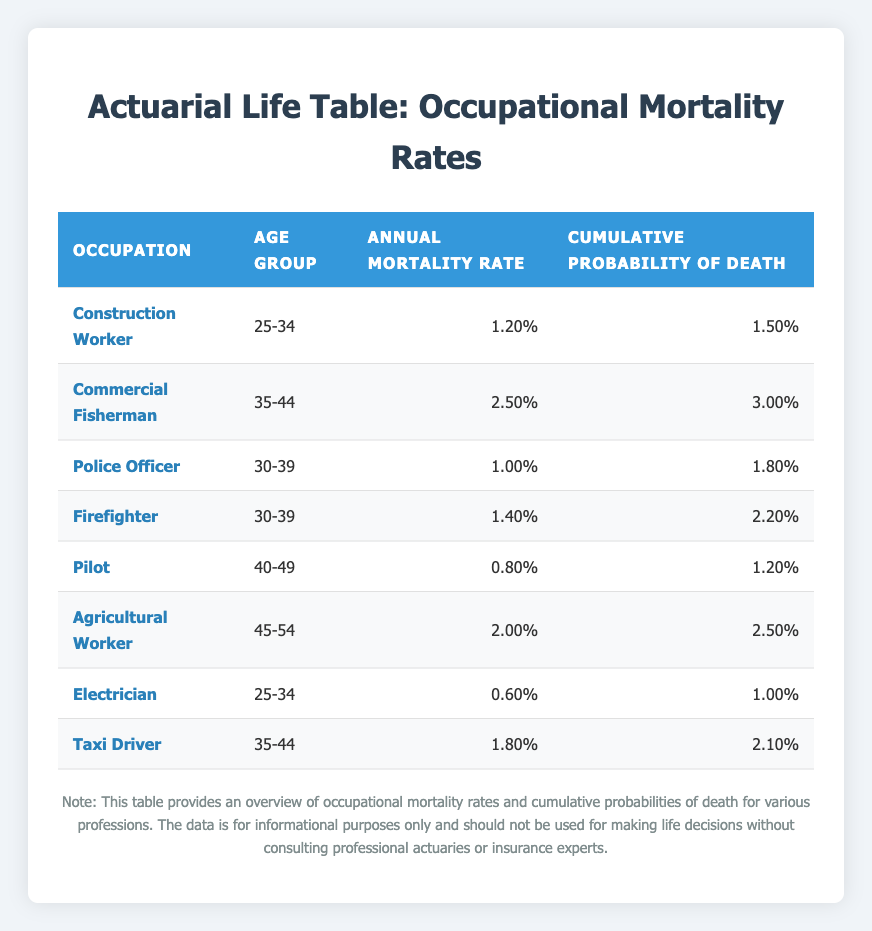What is the annual mortality rate for a Commercial Fisherman? The table lists the annual mortality rate for each occupation. For Commercial Fisherman, it is specifically mentioned as 2.50%.
Answer: 2.50% Which occupation has the highest cumulative probability of death in the age group 30-39? In the age group 30-39, there are two occupations: Police Officer with a cumulative probability of 1.80% and Firefighter with 2.20%. Firefighter has the highest cumulative probability of death at 2.20%.
Answer: Firefighter True or False: The annual mortality rate for Electricians is higher than that for Pilots. The annual mortality rate for Electricians is 0.60%, while for Pilots, it is 0.80%. Therefore, the statement is false since Electricians have a lower rate.
Answer: False What is the cumulative probability of death for Taxi Drivers in the 35-44 age group? The cumulative probability of death for Taxi Drivers in the age group 35-44 is explicitly stated in the table, which is 2.10%.
Answer: 2.10% If we average the annual mortality rates of Police Officers and Firefighters, what do we get? The annual mortality rate for Police Officers is 1.00% and for Firefighters is 1.40%. The average calculation involves summing these rates (1.00 + 1.40 = 2.40) and then dividing by 2 (2.40 / 2 = 1.20%). Thus, the average annual mortality rate of these two occupations is 1.20%.
Answer: 1.20% 